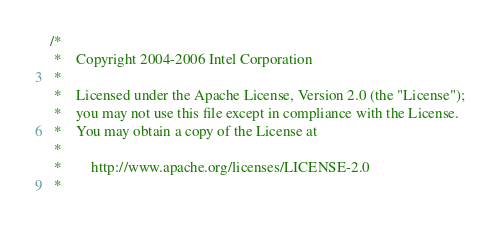Convert code to text. <code><loc_0><loc_0><loc_500><loc_500><_C_>/*
 *    Copyright 2004-2006 Intel Corporation
 * 
 *    Licensed under the Apache License, Version 2.0 (the "License");
 *    you may not use this file except in compliance with the License.
 *    You may obtain a copy of the License at
 * 
 *        http://www.apache.org/licenses/LICENSE-2.0
 * </code> 